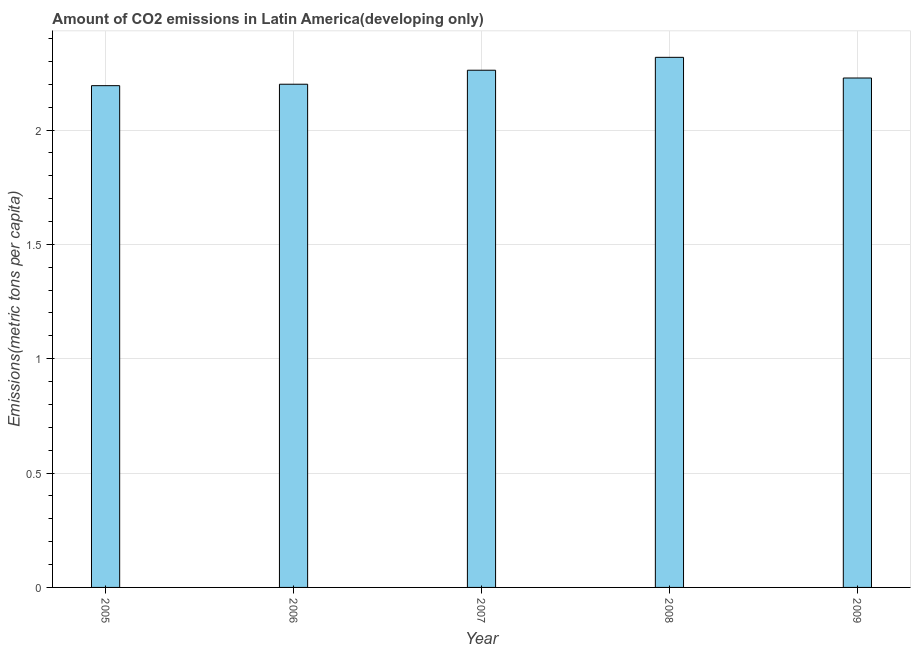Does the graph contain grids?
Offer a very short reply. Yes. What is the title of the graph?
Make the answer very short. Amount of CO2 emissions in Latin America(developing only). What is the label or title of the Y-axis?
Make the answer very short. Emissions(metric tons per capita). What is the amount of co2 emissions in 2006?
Your response must be concise. 2.2. Across all years, what is the maximum amount of co2 emissions?
Offer a terse response. 2.32. Across all years, what is the minimum amount of co2 emissions?
Give a very brief answer. 2.19. In which year was the amount of co2 emissions maximum?
Your response must be concise. 2008. What is the sum of the amount of co2 emissions?
Ensure brevity in your answer.  11.2. What is the difference between the amount of co2 emissions in 2007 and 2008?
Your answer should be compact. -0.06. What is the average amount of co2 emissions per year?
Your answer should be very brief. 2.24. What is the median amount of co2 emissions?
Keep it short and to the point. 2.23. What is the ratio of the amount of co2 emissions in 2006 to that in 2007?
Your response must be concise. 0.97. Is the difference between the amount of co2 emissions in 2005 and 2007 greater than the difference between any two years?
Your answer should be very brief. No. What is the difference between the highest and the second highest amount of co2 emissions?
Your answer should be compact. 0.06. What is the difference between the highest and the lowest amount of co2 emissions?
Make the answer very short. 0.12. How many years are there in the graph?
Your answer should be compact. 5. What is the difference between two consecutive major ticks on the Y-axis?
Offer a terse response. 0.5. What is the Emissions(metric tons per capita) in 2005?
Offer a very short reply. 2.19. What is the Emissions(metric tons per capita) in 2006?
Ensure brevity in your answer.  2.2. What is the Emissions(metric tons per capita) of 2007?
Ensure brevity in your answer.  2.26. What is the Emissions(metric tons per capita) in 2008?
Your answer should be compact. 2.32. What is the Emissions(metric tons per capita) of 2009?
Provide a short and direct response. 2.23. What is the difference between the Emissions(metric tons per capita) in 2005 and 2006?
Your answer should be very brief. -0.01. What is the difference between the Emissions(metric tons per capita) in 2005 and 2007?
Provide a short and direct response. -0.07. What is the difference between the Emissions(metric tons per capita) in 2005 and 2008?
Your answer should be compact. -0.12. What is the difference between the Emissions(metric tons per capita) in 2005 and 2009?
Offer a very short reply. -0.03. What is the difference between the Emissions(metric tons per capita) in 2006 and 2007?
Offer a terse response. -0.06. What is the difference between the Emissions(metric tons per capita) in 2006 and 2008?
Offer a very short reply. -0.12. What is the difference between the Emissions(metric tons per capita) in 2006 and 2009?
Give a very brief answer. -0.03. What is the difference between the Emissions(metric tons per capita) in 2007 and 2008?
Offer a very short reply. -0.06. What is the difference between the Emissions(metric tons per capita) in 2007 and 2009?
Offer a terse response. 0.03. What is the difference between the Emissions(metric tons per capita) in 2008 and 2009?
Your response must be concise. 0.09. What is the ratio of the Emissions(metric tons per capita) in 2005 to that in 2006?
Your answer should be compact. 1. What is the ratio of the Emissions(metric tons per capita) in 2005 to that in 2008?
Provide a succinct answer. 0.95. What is the ratio of the Emissions(metric tons per capita) in 2006 to that in 2008?
Make the answer very short. 0.95. What is the ratio of the Emissions(metric tons per capita) in 2007 to that in 2008?
Your response must be concise. 0.98. What is the ratio of the Emissions(metric tons per capita) in 2008 to that in 2009?
Give a very brief answer. 1.04. 